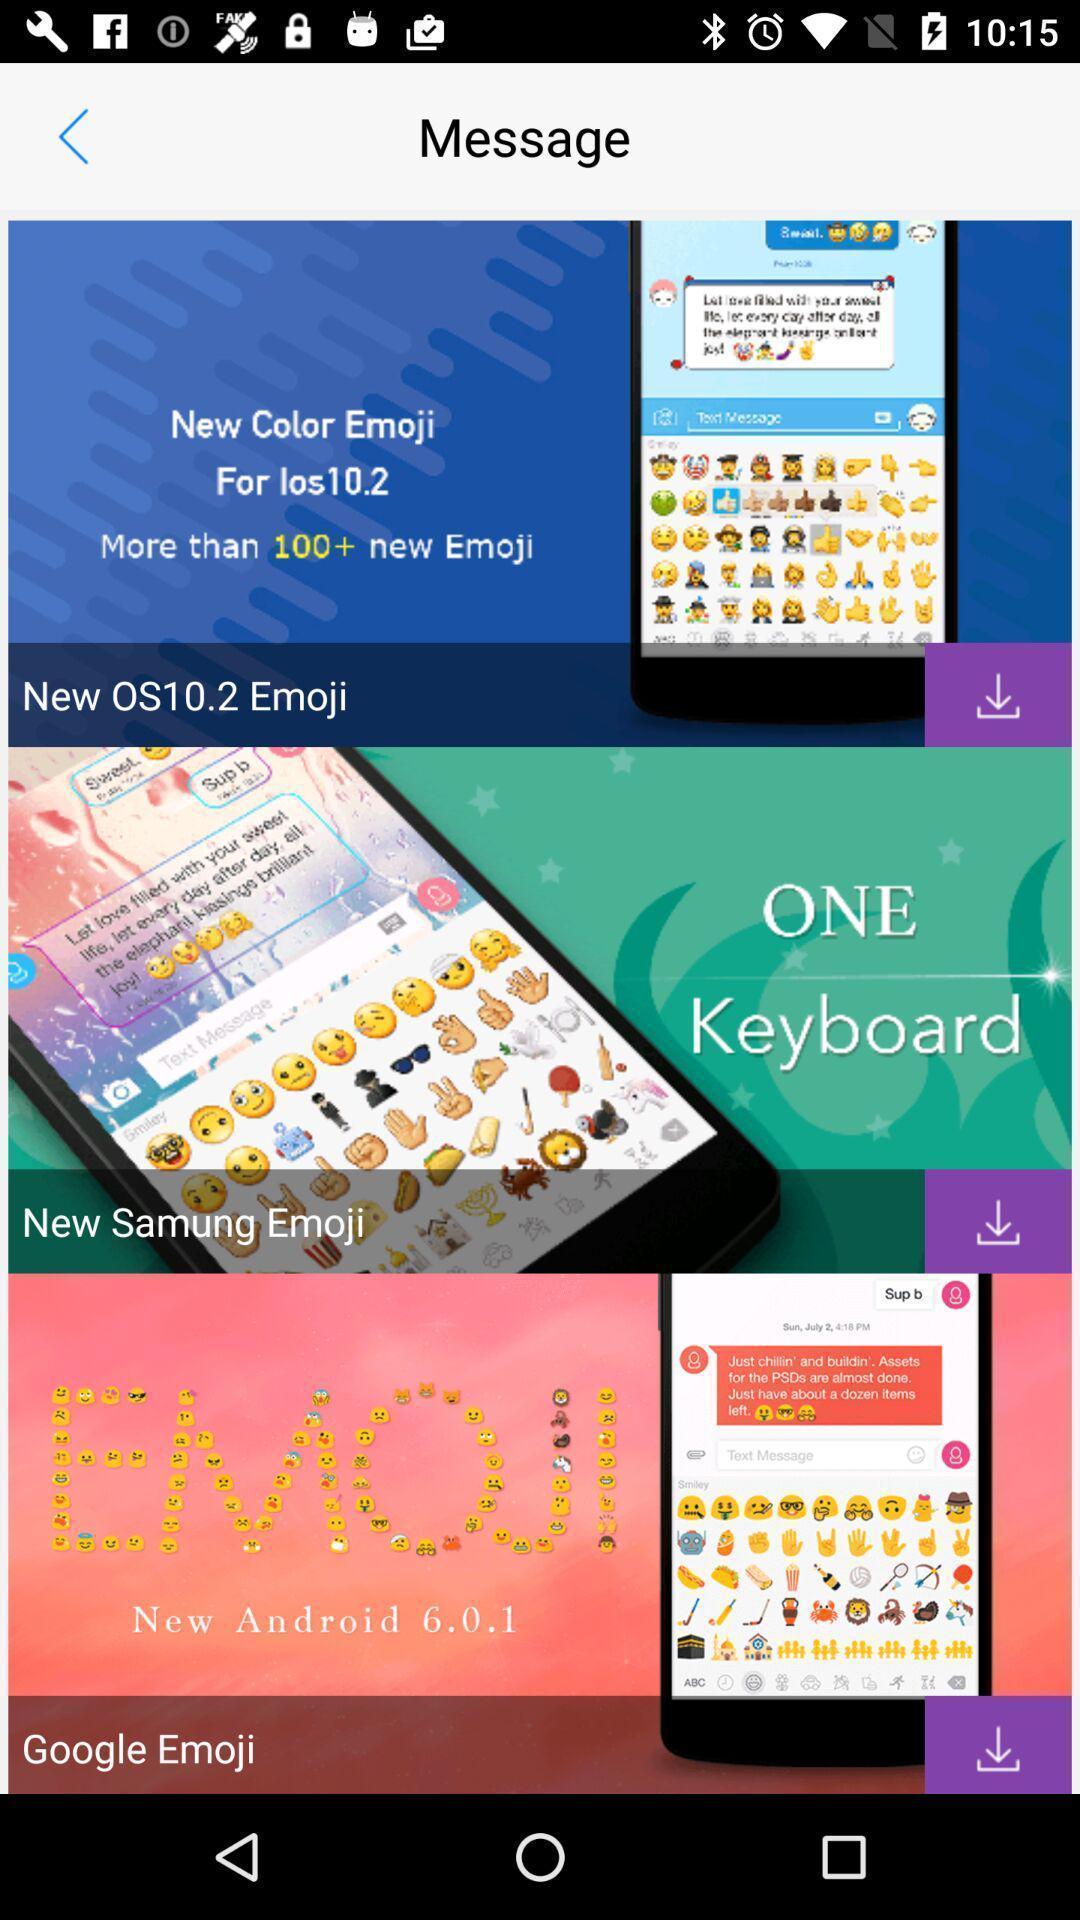Summarize the main components in this picture. Page showing various keyboards for messaging. 